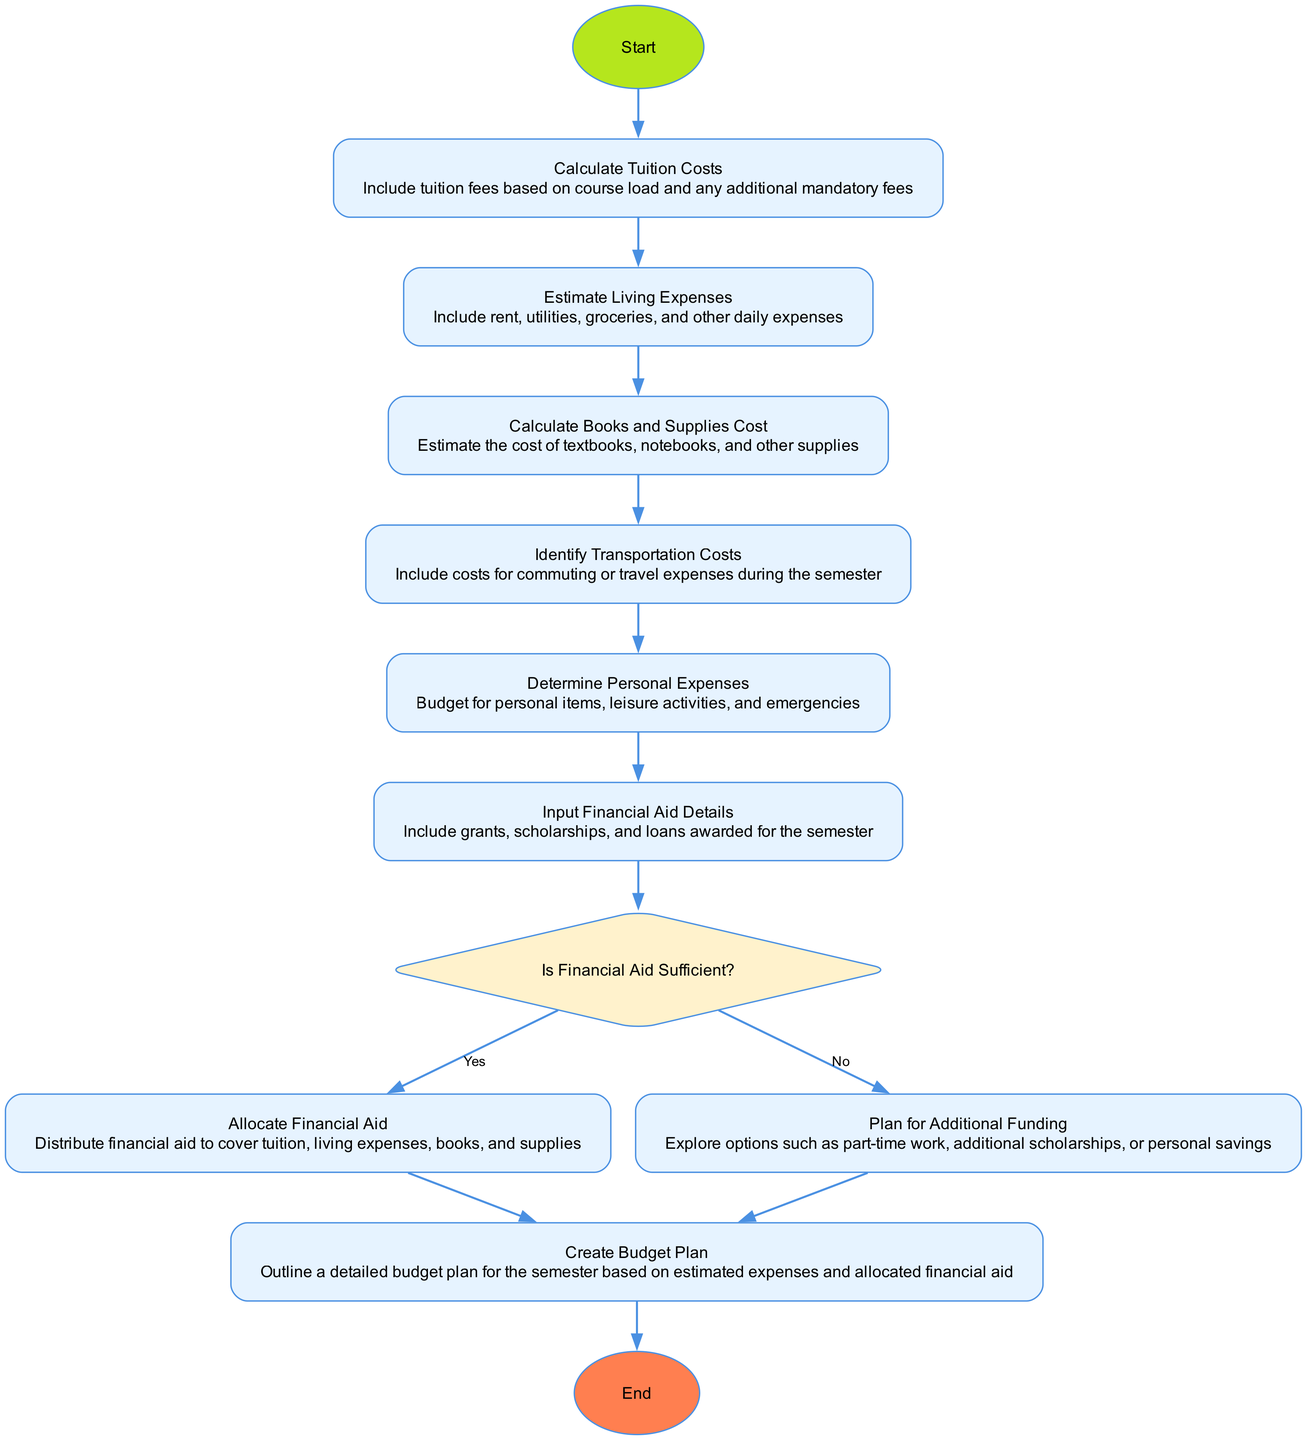What is the first step in the diagram? The first step in the diagram is labeled "Start." It represents the initiation of the budgeting process.
Answer: Start How many decision nodes are in the diagram? There is one decision node in the diagram, which is the "Is Financial Aid Sufficient?" node.
Answer: 1 What do you do if financial aid is not sufficient? If financial aid is not sufficient, the flowchart indicates to "Plan for Additional Funding," where options such as part-time work or extra scholarships can be explored.
Answer: Plan for Additional Funding What is included in estimating living expenses? Estimating living expenses includes rent, utilities, groceries, and other daily expenses.
Answer: Rent, utilities, groceries What comes after calculating tuition costs? After calculating tuition costs, the next step is to "Estimate Living Expenses." This involves considering all housing-related expenses necessary for living during the semester.
Answer: Estimate Living Expenses What is the final process before reaching the end of the diagram? The final process before reaching the end of the diagram is "Create Budget Plan," which outlines a detailed budget based on expenses and financial aid.
Answer: Create Budget Plan How does financial aid get allocated if it is sufficient? If financial aid is sufficient, it gets allocated to cover tuition, living expenses, books, and supplies as indicated in the flowchart.
Answer: Allocate Financial Aid What types of expenses do personal expenses include? Personal expenses include budget for personal items, leisure activities, and emergencies as described in the flowchart.
Answer: Personal items, leisure activities, emergencies 